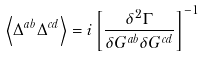<formula> <loc_0><loc_0><loc_500><loc_500>\left \langle \Delta ^ { a b } \Delta ^ { c d } \right \rangle = i \left [ \frac { \delta ^ { 2 } \Gamma } { \delta G ^ { a b } \delta G ^ { c d } } \right ] ^ { - 1 }</formula> 